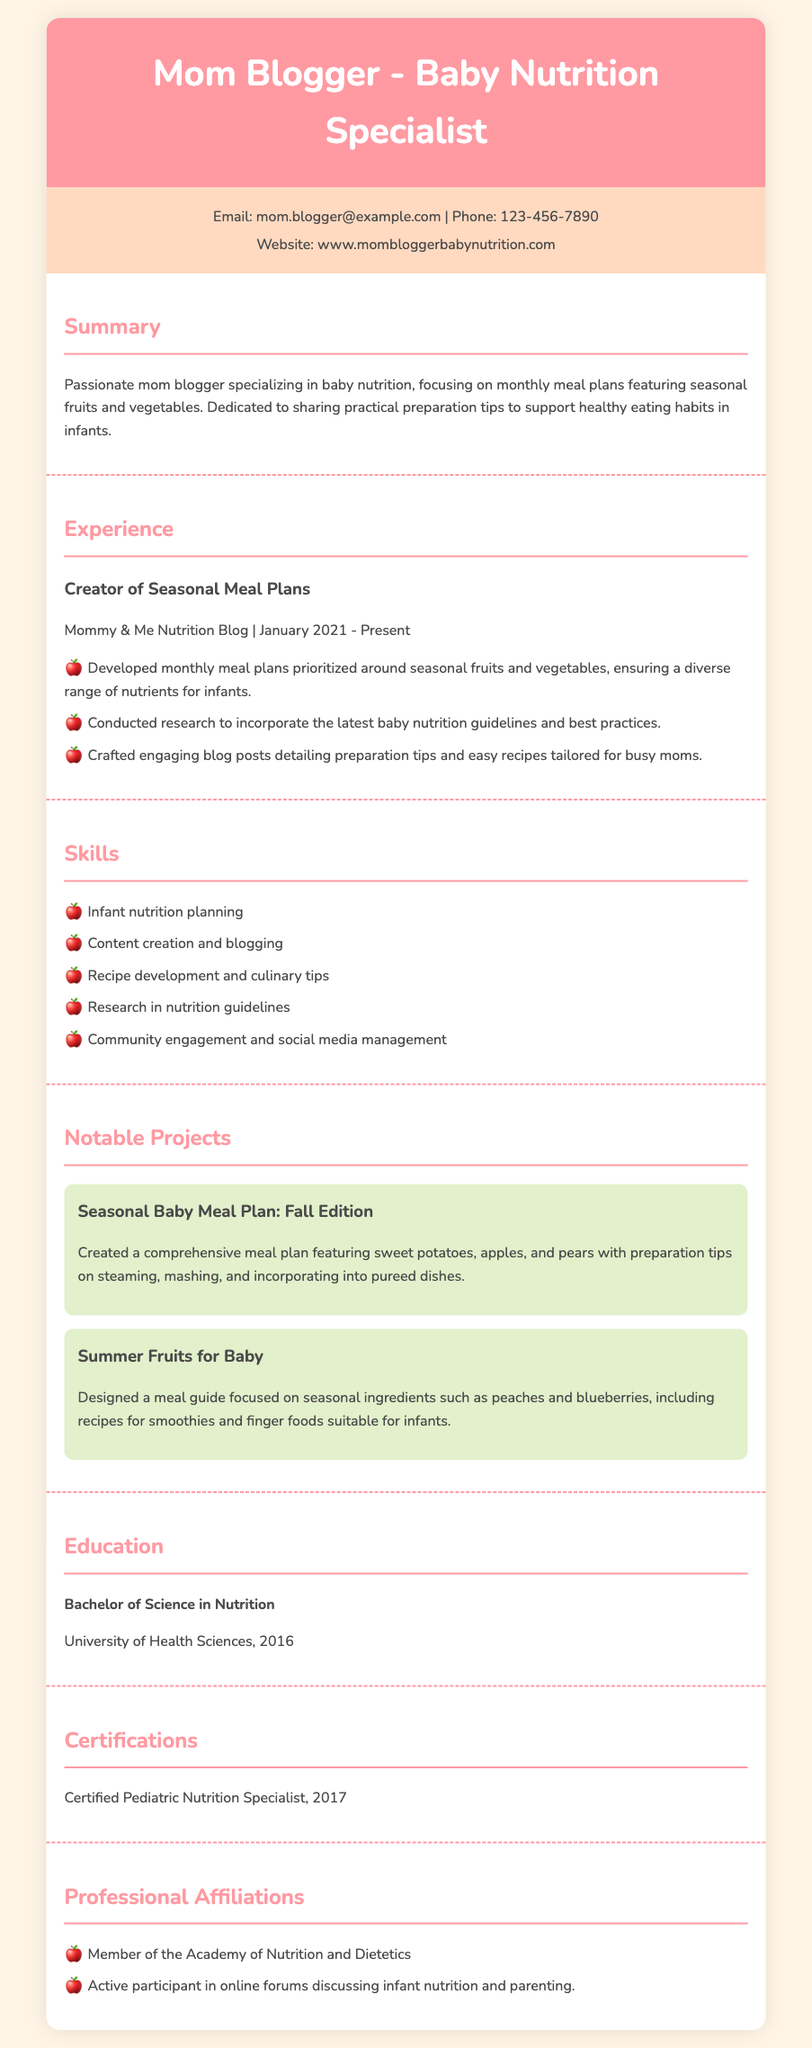what is the website of the mom blogger? The website is provided in the contact information section of the resume.
Answer: www.mombloggerbabynutrition.com what is the degree obtained by the mom blogger? The degree is mentioned in the education section of the resume.
Answer: Bachelor of Science in Nutrition in what year did the mom blogger start her nutrition blog? The start date is given in the experience section of the resume.
Answer: January 2021 what notable project focuses on summer fruits? The project is listed in the notable projects section.
Answer: Summer Fruits for Baby how many skills are listed in the skills section? The number of skills is counted in the skills section of the resume.
Answer: 5 what preparation tips are included in the Fall Edition meal plan? The preparation tips are part of the notable project description in the resume.
Answer: steaming, mashing, and incorporating into pureed dishes which professional organization is she a member of? The membership is stated in the professional affiliations section of the resume.
Answer: Academy of Nutrition and Dietetics what is the certification obtained by the mom blogger? The certification is mentioned in the certifications section of the resume.
Answer: Certified Pediatric Nutrition Specialist 